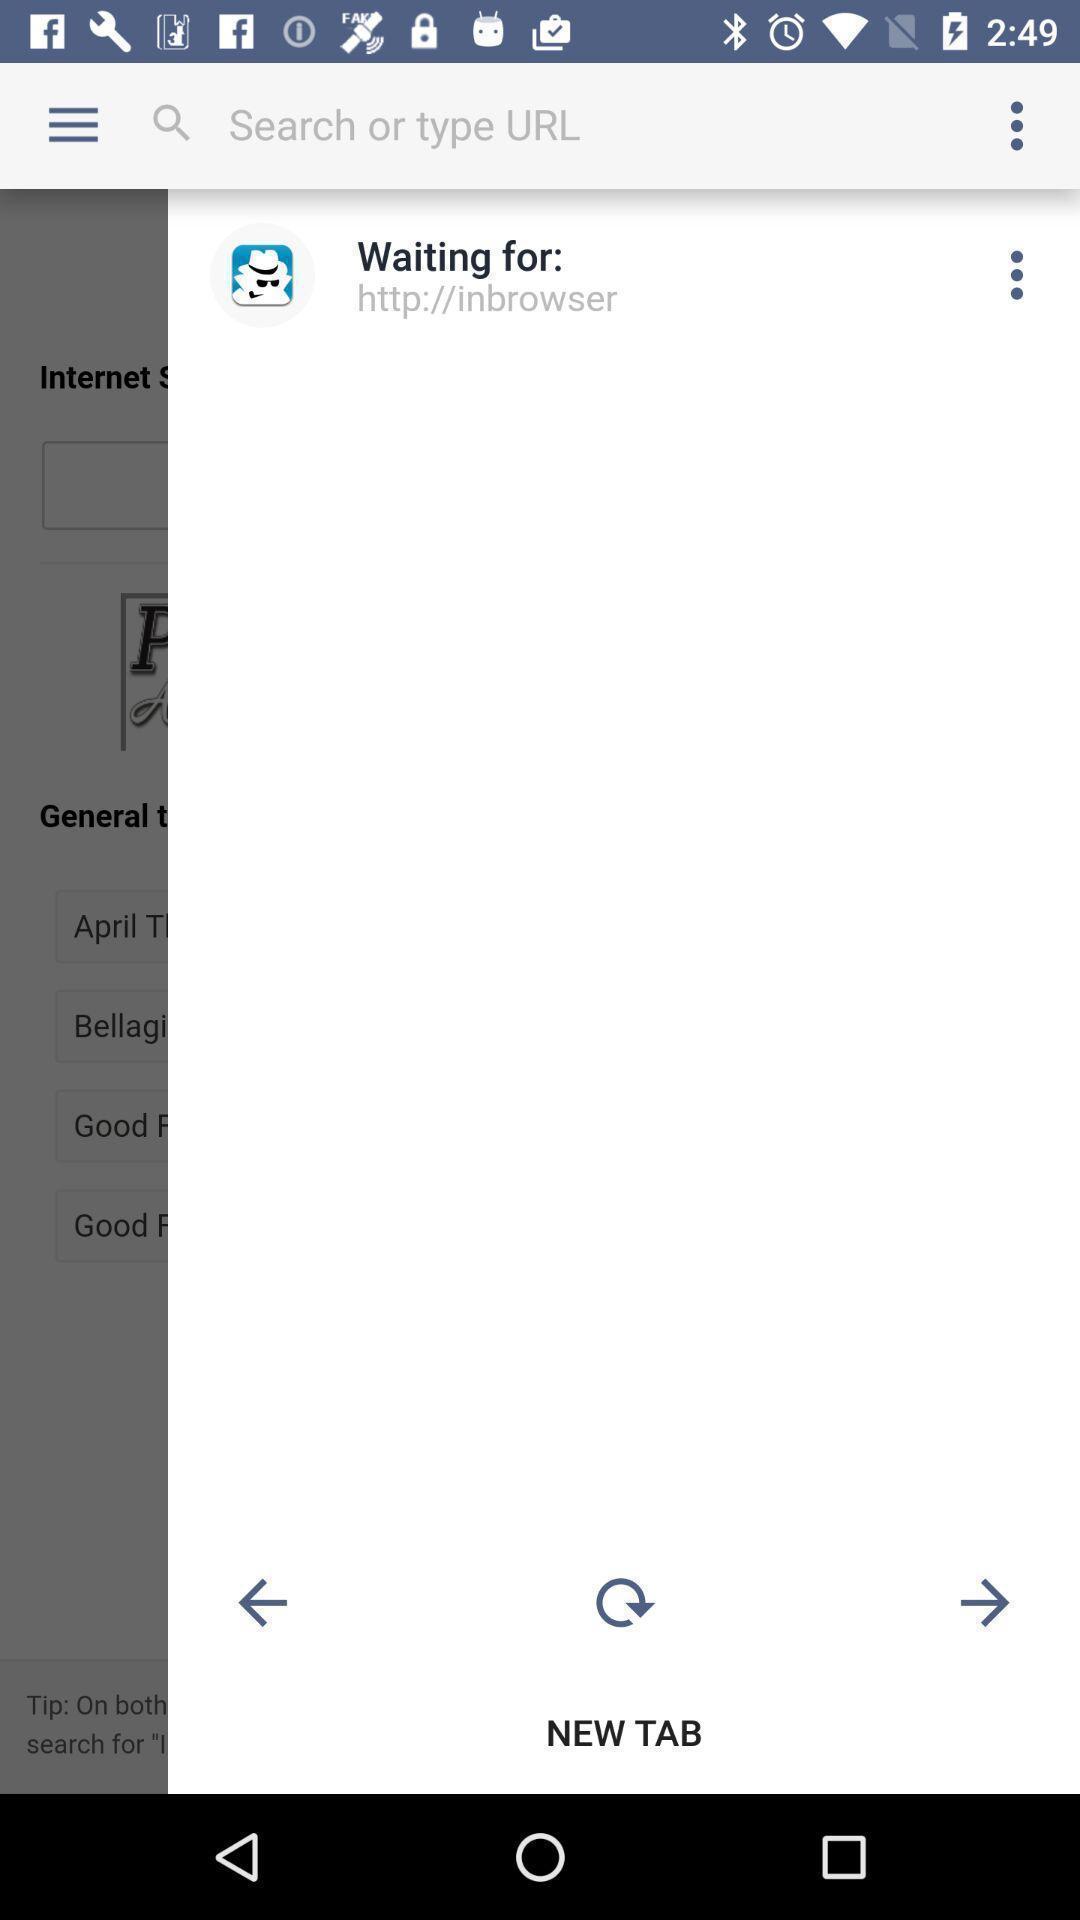Describe the content in this image. Result page for a searched website. 